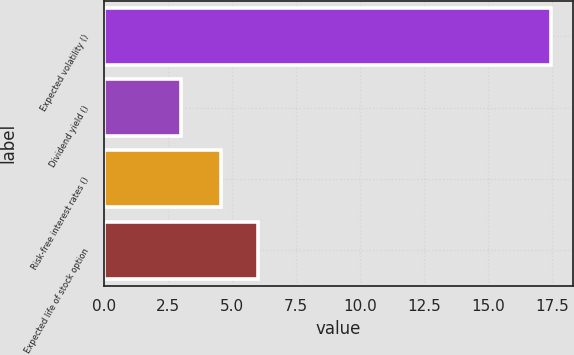Convert chart. <chart><loc_0><loc_0><loc_500><loc_500><bar_chart><fcel>Expected volatility ()<fcel>Dividend yield ()<fcel>Risk-free interest rates ()<fcel>Expected life of stock option<nl><fcel>17.45<fcel>3<fcel>4.58<fcel>6.03<nl></chart> 